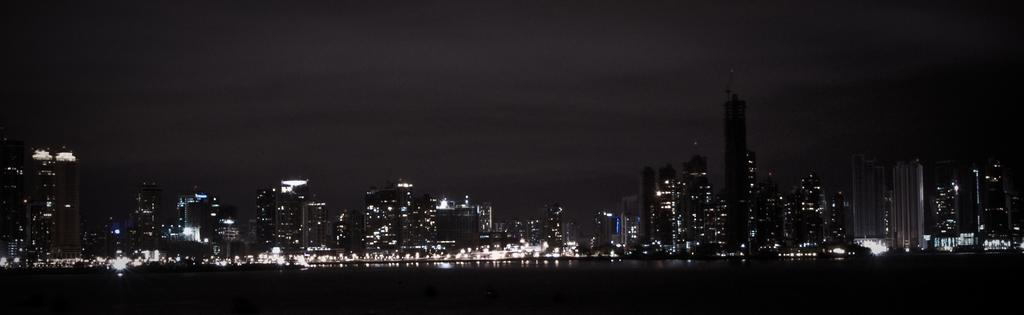What types of structures are present in the image? There are multiple buildings in the image. What can be seen illuminated in the image? There are lights visible in the image. Can you describe the overall lighting condition in the image? The image appears to be in a dark setting. What type of meat is being cooked on the grill in the image? There is no grill or meat present in the image; it features multiple buildings and lights in a dark setting. 